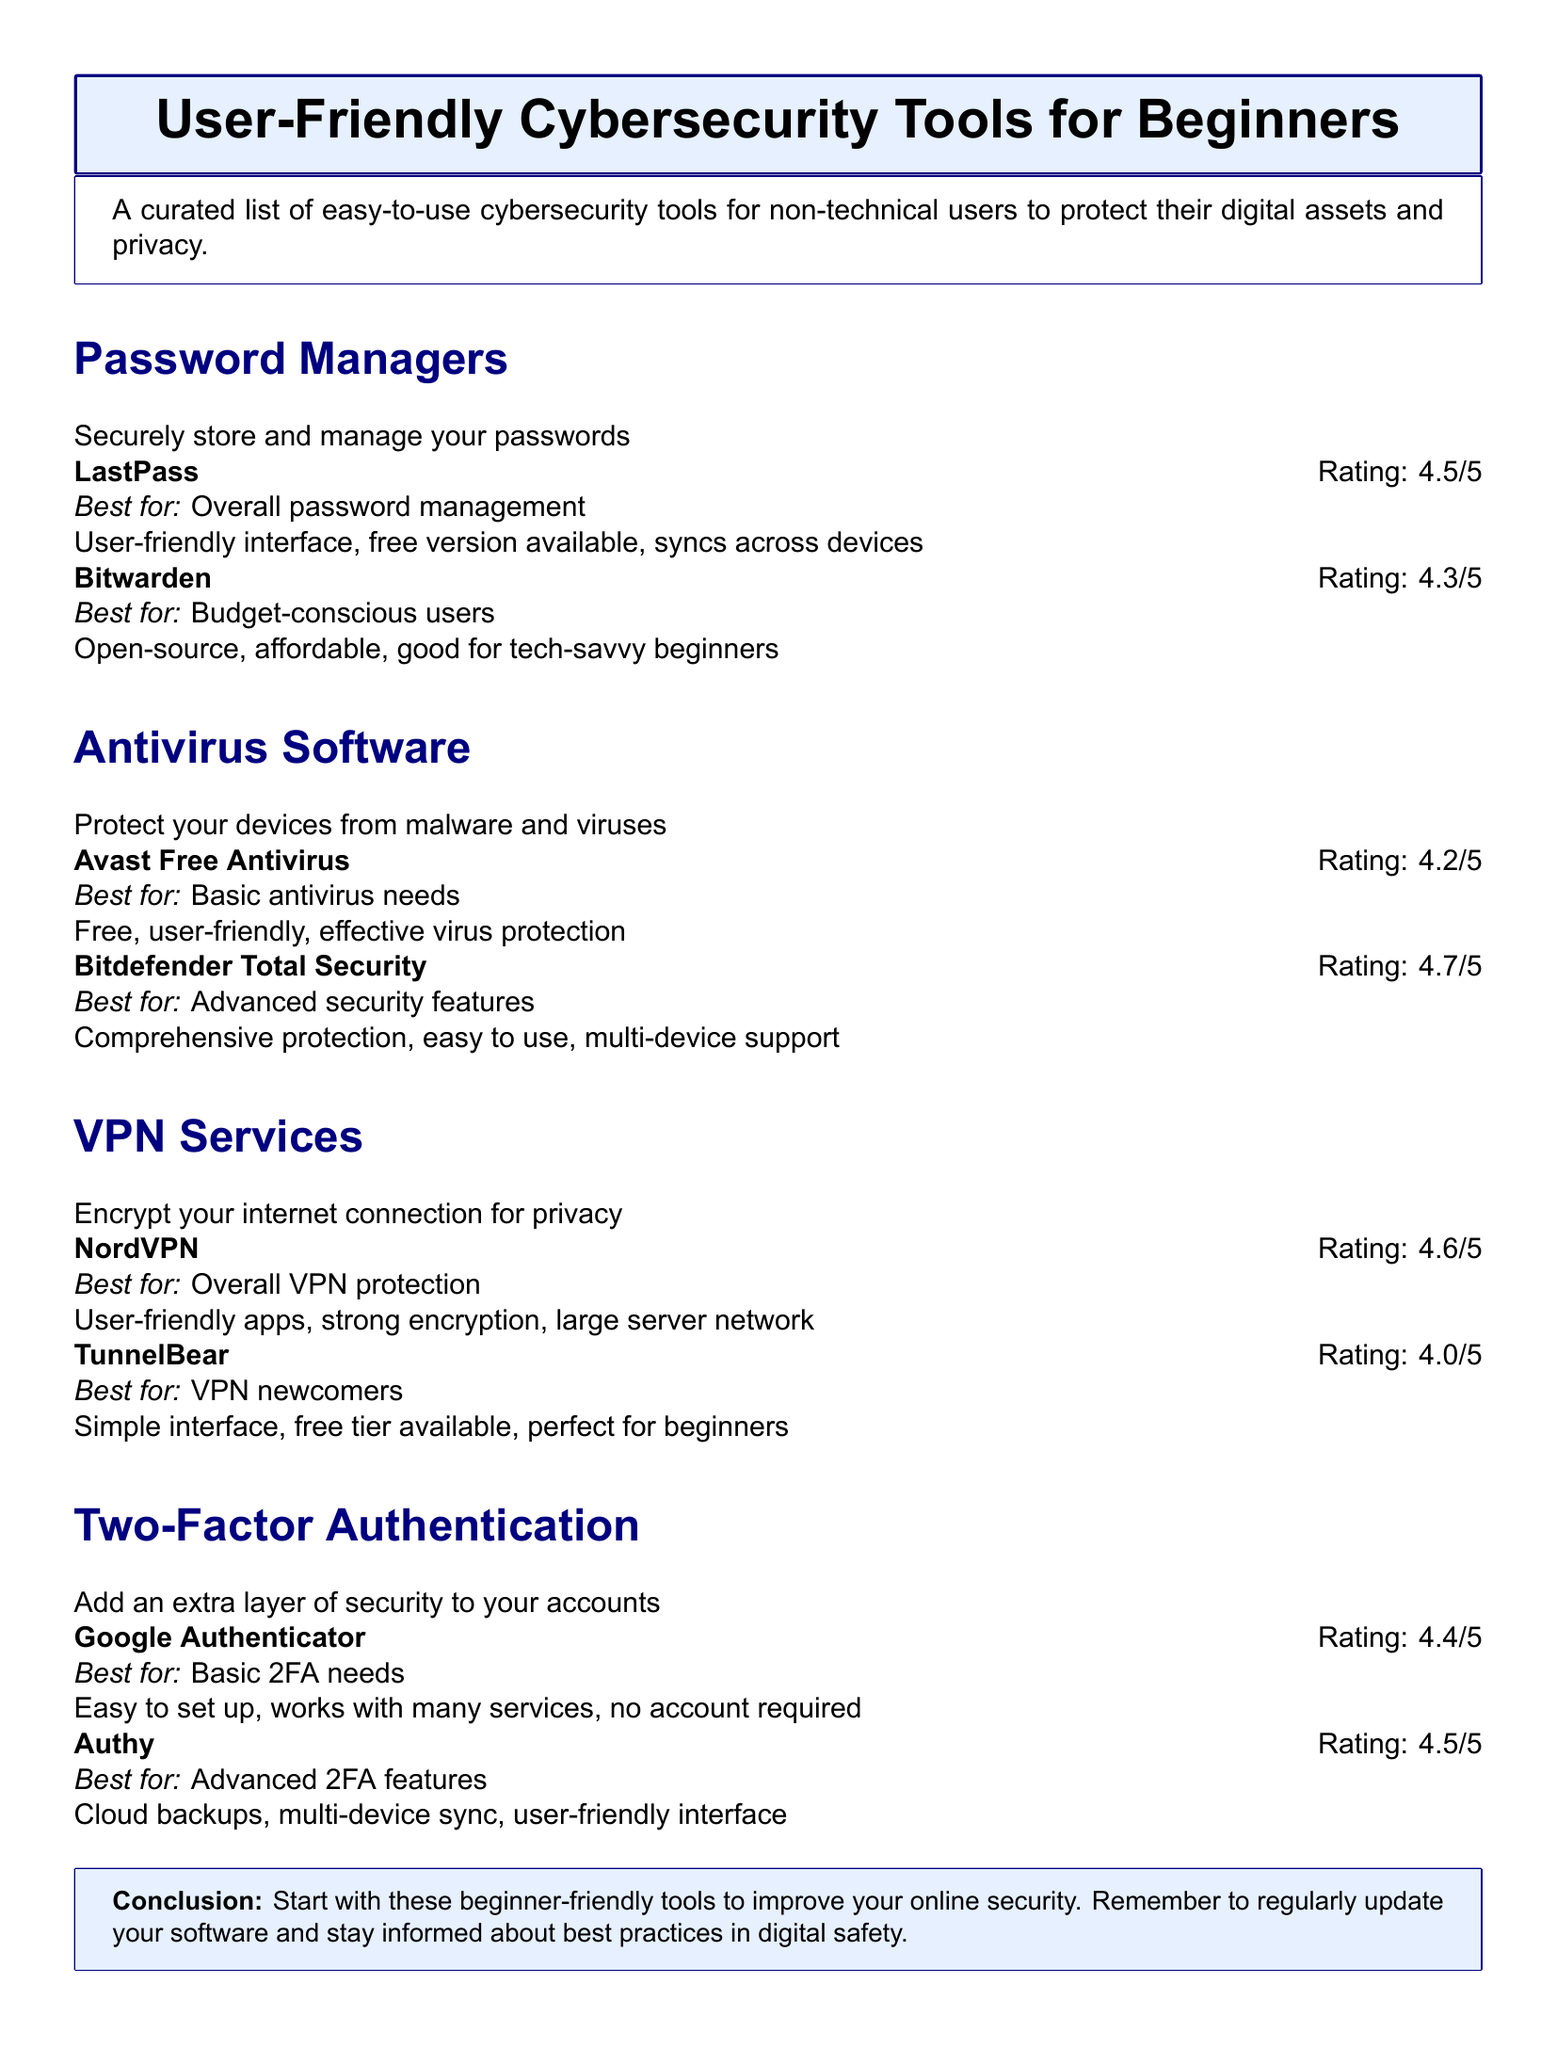What is the highest rating for antivirus software? The highest rating among antivirus software listed is 4.7 for Bitdefender Total Security.
Answer: 4.7 Which password manager has a free version available? LastPass is mentioned to have a free version available in the document.
Answer: LastPass What is the best VPN service for overall protection? NordVPN is highlighted as the best for overall VPN protection in the document.
Answer: NordVPN What tool provides cloud backups for two-factor authentication? Authy is noted for offering cloud backups in the two-factor authentication section.
Answer: Authy How many password managers are listed in the document? There are two password managers mentioned in the document: LastPass and Bitwarden.
Answer: 2 Which antivirus software is considered user-friendly? Avast Free Antivirus is described as user-friendly in the document.
Answer: Avast Free Antivirus What is the rating for TunnelBear as a VPN service? TunnelBear has a rating of 4.0 according to the document.
Answer: 4.0 What is the main purpose of the tools listed in the catalog? The tools are aimed at protecting digital assets and privacy for non-technical users.
Answer: Protecting digital assets and privacy Which tool is best for budget-conscious users? Bitwarden is noted as ideal for budget-conscious users in the password manager section.
Answer: Bitwarden 